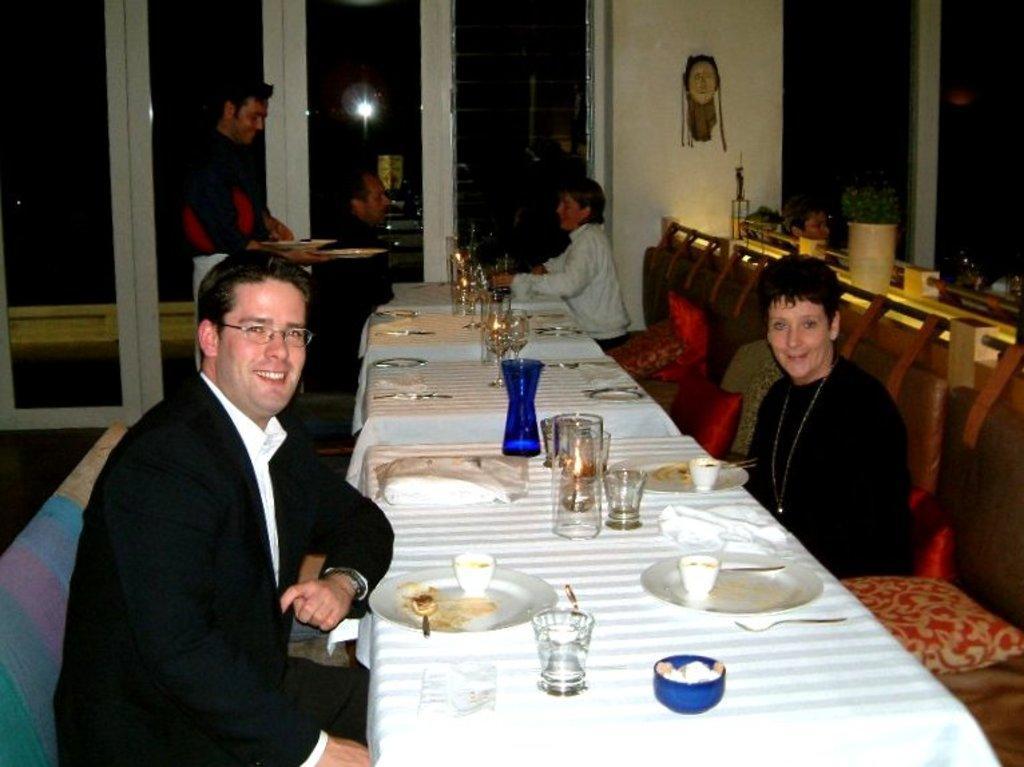In one or two sentences, can you explain what this image depicts? In this image we can see two men and two women sitting on the chairs in front of the dining tables which are covered with white color clothes and on the tables we can see the plates, glasses, candles, cup and also tissues. We can also see the cushions, flower pot and also the depiction of human toy attached to the wall. There is a person standing and holding the plates. 